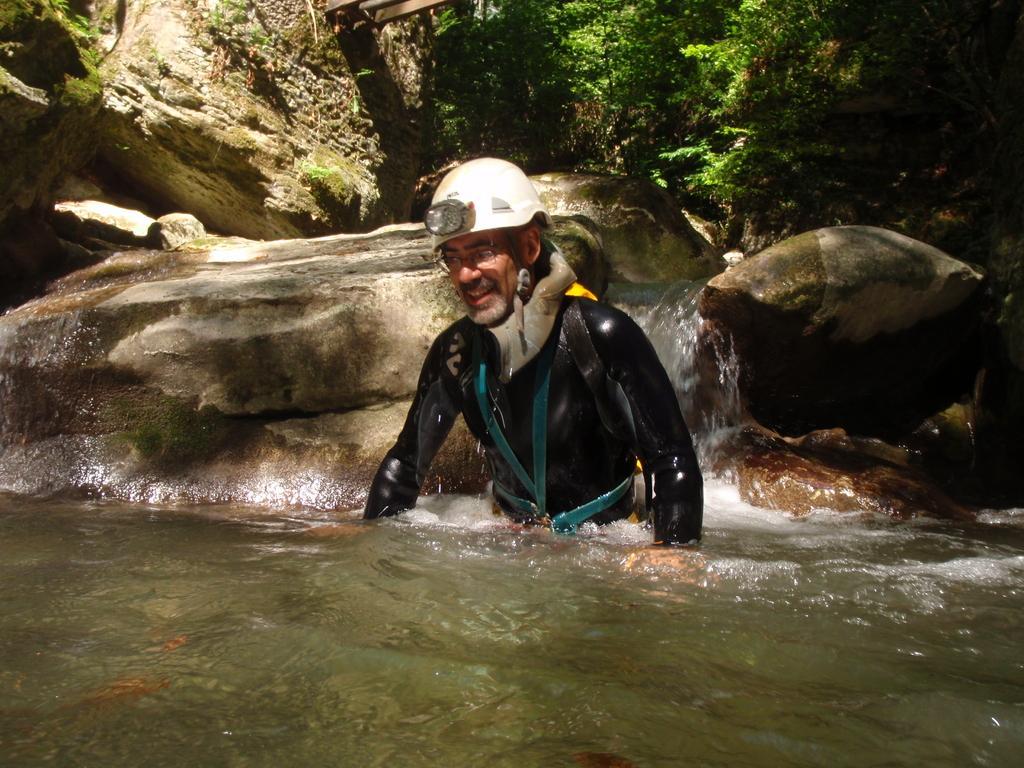In one or two sentences, can you explain what this image depicts? In this image, we can see a person wearing a helmet and in the water. In the background, we can see stones, waterfall and plants. 